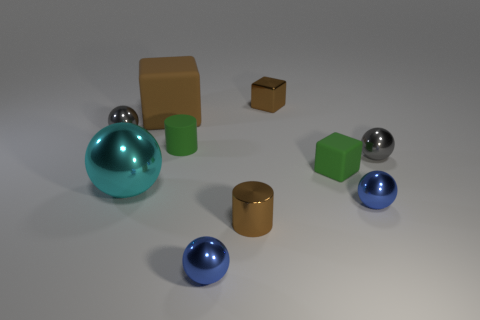Is the color of the big cube behind the large metal sphere the same as the cylinder that is in front of the tiny green matte cube?
Your response must be concise. Yes. There is a big brown matte thing; what number of small gray metal objects are on the right side of it?
Offer a very short reply. 1. How many metal objects have the same color as the shiny cylinder?
Give a very brief answer. 1. Is the material of the gray thing left of the big cyan metallic object the same as the green cylinder?
Keep it short and to the point. No. What number of large brown objects have the same material as the large brown cube?
Make the answer very short. 0. Is the number of small gray metallic things to the right of the brown cylinder greater than the number of tiny matte spheres?
Make the answer very short. Yes. There is a rubber thing that is the same color as the metallic cylinder; what is its size?
Give a very brief answer. Large. Is there another object of the same shape as the big cyan metallic thing?
Provide a short and direct response. Yes. How many objects are green matte objects or brown cubes?
Make the answer very short. 4. There is a small cylinder behind the green thing that is right of the brown metallic block; how many big spheres are to the right of it?
Your answer should be very brief. 0. 